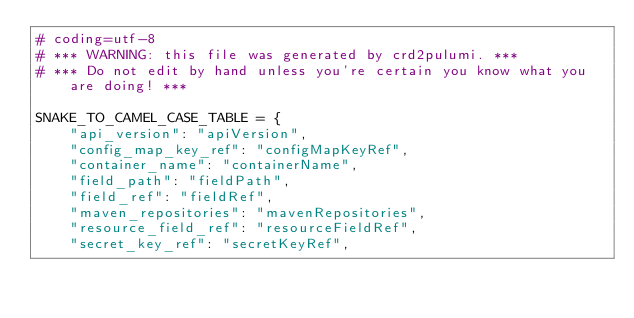<code> <loc_0><loc_0><loc_500><loc_500><_Python_># coding=utf-8
# *** WARNING: this file was generated by crd2pulumi. ***
# *** Do not edit by hand unless you're certain you know what you are doing! ***

SNAKE_TO_CAMEL_CASE_TABLE = {
    "api_version": "apiVersion",
    "config_map_key_ref": "configMapKeyRef",
    "container_name": "containerName",
    "field_path": "fieldPath",
    "field_ref": "fieldRef",
    "maven_repositories": "mavenRepositories",
    "resource_field_ref": "resourceFieldRef",
    "secret_key_ref": "secretKeyRef",</code> 